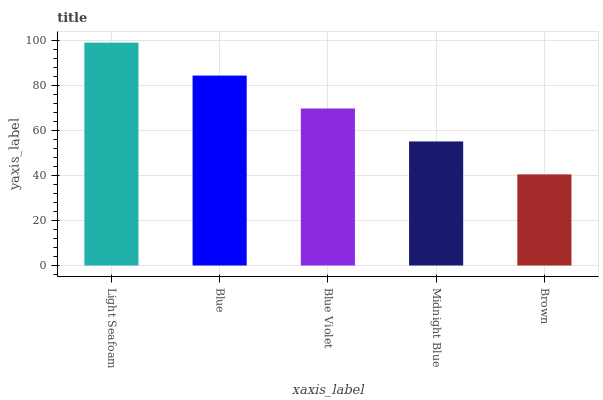Is Blue the minimum?
Answer yes or no. No. Is Blue the maximum?
Answer yes or no. No. Is Light Seafoam greater than Blue?
Answer yes or no. Yes. Is Blue less than Light Seafoam?
Answer yes or no. Yes. Is Blue greater than Light Seafoam?
Answer yes or no. No. Is Light Seafoam less than Blue?
Answer yes or no. No. Is Blue Violet the high median?
Answer yes or no. Yes. Is Blue Violet the low median?
Answer yes or no. Yes. Is Blue the high median?
Answer yes or no. No. Is Brown the low median?
Answer yes or no. No. 